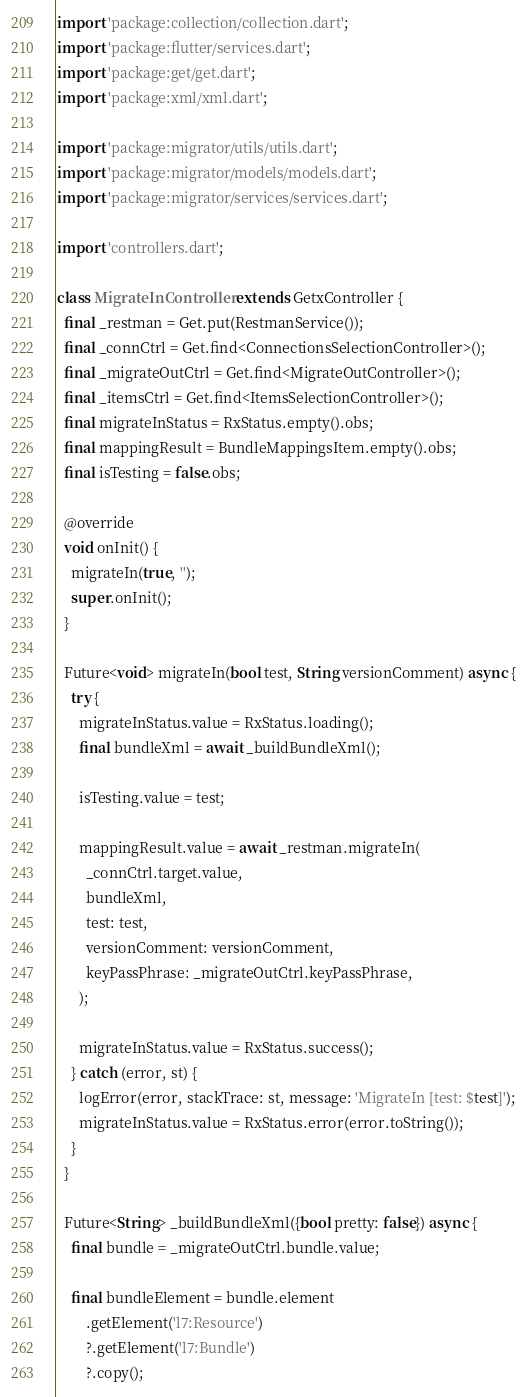<code> <loc_0><loc_0><loc_500><loc_500><_Dart_>import 'package:collection/collection.dart';
import 'package:flutter/services.dart';
import 'package:get/get.dart';
import 'package:xml/xml.dart';

import 'package:migrator/utils/utils.dart';
import 'package:migrator/models/models.dart';
import 'package:migrator/services/services.dart';

import 'controllers.dart';

class MigrateInController extends GetxController {
  final _restman = Get.put(RestmanService());
  final _connCtrl = Get.find<ConnectionsSelectionController>();
  final _migrateOutCtrl = Get.find<MigrateOutController>();
  final _itemsCtrl = Get.find<ItemsSelectionController>();
  final migrateInStatus = RxStatus.empty().obs;
  final mappingResult = BundleMappingsItem.empty().obs;
  final isTesting = false.obs;

  @override
  void onInit() {
    migrateIn(true, '');
    super.onInit();
  }

  Future<void> migrateIn(bool test, String versionComment) async {
    try {
      migrateInStatus.value = RxStatus.loading();
      final bundleXml = await _buildBundleXml();

      isTesting.value = test;

      mappingResult.value = await _restman.migrateIn(
        _connCtrl.target.value,
        bundleXml,
        test: test,
        versionComment: versionComment,
        keyPassPhrase: _migrateOutCtrl.keyPassPhrase,
      );

      migrateInStatus.value = RxStatus.success();
    } catch (error, st) {
      logError(error, stackTrace: st, message: 'MigrateIn [test: $test]');
      migrateInStatus.value = RxStatus.error(error.toString());
    }
  }

  Future<String> _buildBundleXml({bool pretty: false}) async {
    final bundle = _migrateOutCtrl.bundle.value;

    final bundleElement = bundle.element
        .getElement('l7:Resource')
        ?.getElement('l7:Bundle')
        ?.copy();
</code> 